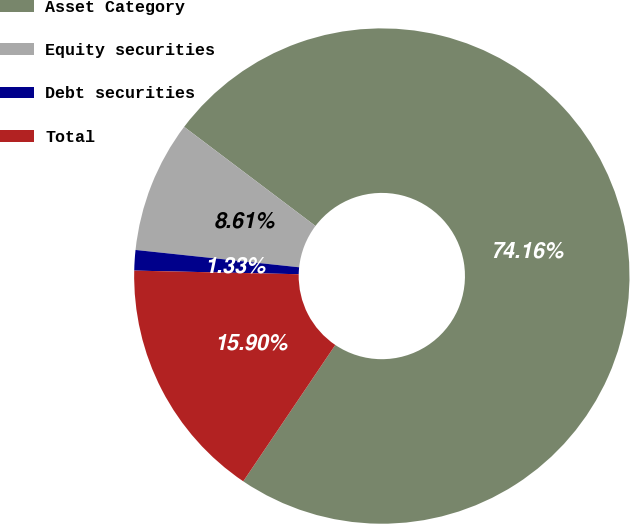<chart> <loc_0><loc_0><loc_500><loc_500><pie_chart><fcel>Asset Category<fcel>Equity securities<fcel>Debt securities<fcel>Total<nl><fcel>74.16%<fcel>8.61%<fcel>1.33%<fcel>15.9%<nl></chart> 